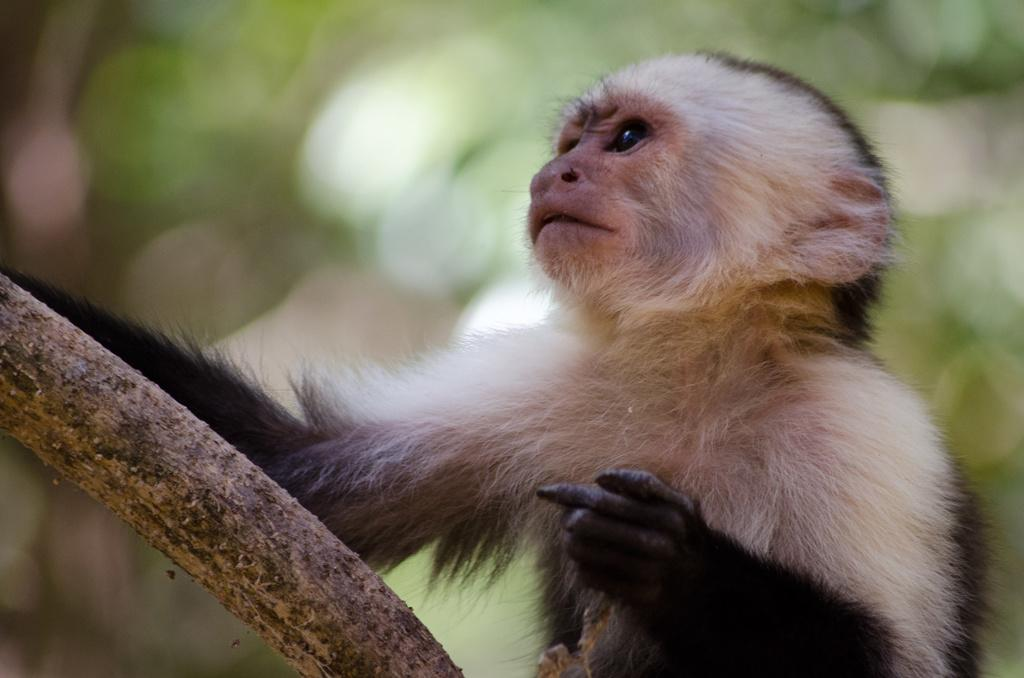What type of animal is in the image? There is a monkey in the image. What color pattern does the monkey have? The monkey has a black and white color. What material is the object in the image made of? The object in the image is made of wood. How would you describe the image's background? The image's background is blurry. What word does the monkey say in the image? There is no indication in the image that the monkey is saying any words. Can you see the monkey's breath in the image? The image does not show the monkey's breath, as it is not cold enough for visible breath. 